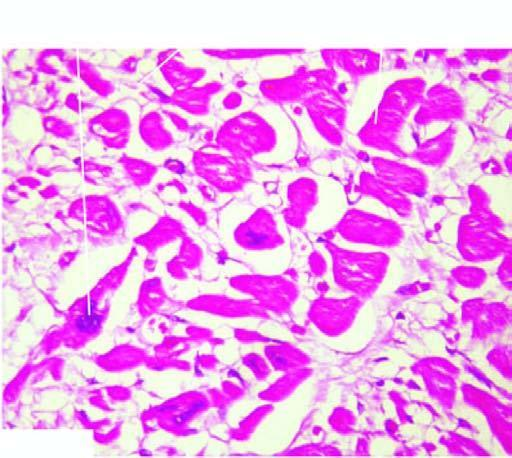what are nuclei also enlarged with?
Answer the question using a single word or phrase. Irregular outlines 